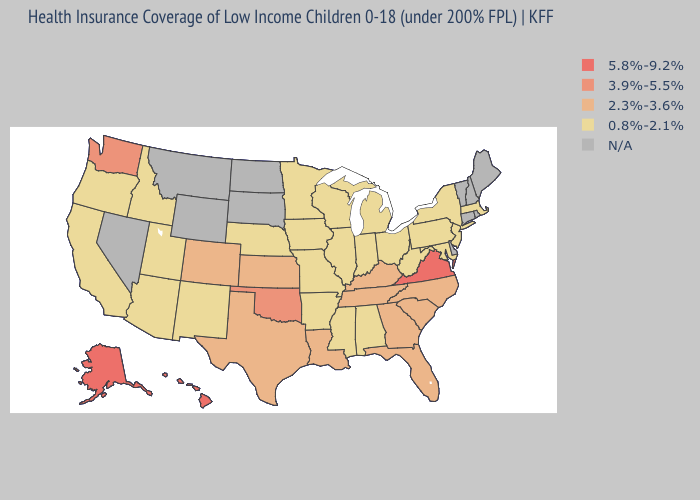Name the states that have a value in the range 2.3%-3.6%?
Give a very brief answer. Colorado, Florida, Georgia, Kansas, Kentucky, Louisiana, North Carolina, South Carolina, Tennessee, Texas. What is the highest value in the West ?
Quick response, please. 5.8%-9.2%. Name the states that have a value in the range 2.3%-3.6%?
Short answer required. Colorado, Florida, Georgia, Kansas, Kentucky, Louisiana, North Carolina, South Carolina, Tennessee, Texas. Name the states that have a value in the range 5.8%-9.2%?
Quick response, please. Alaska, Hawaii, Virginia. What is the value of Rhode Island?
Quick response, please. N/A. What is the lowest value in the South?
Short answer required. 0.8%-2.1%. How many symbols are there in the legend?
Keep it brief. 5. What is the lowest value in the USA?
Be succinct. 0.8%-2.1%. Name the states that have a value in the range 5.8%-9.2%?
Quick response, please. Alaska, Hawaii, Virginia. What is the value of Wisconsin?
Short answer required. 0.8%-2.1%. What is the value of Hawaii?
Concise answer only. 5.8%-9.2%. Name the states that have a value in the range 2.3%-3.6%?
Write a very short answer. Colorado, Florida, Georgia, Kansas, Kentucky, Louisiana, North Carolina, South Carolina, Tennessee, Texas. 